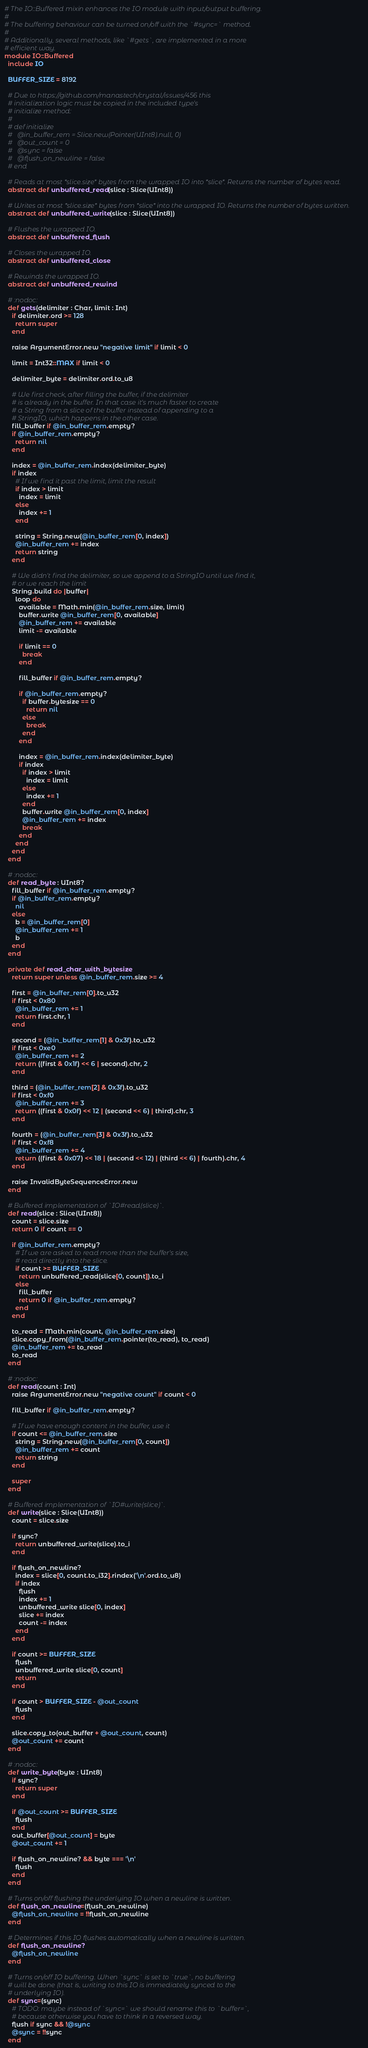Convert code to text. <code><loc_0><loc_0><loc_500><loc_500><_Crystal_># The IO::Buffered mixin enhances the IO module with input/output buffering.
#
# The buffering behaviour can be turned on/off with the `#sync=` method.
#
# Additionally, several methods, like `#gets`, are implemented in a more
# efficient way.
module IO::Buffered
  include IO

  BUFFER_SIZE = 8192

  # Due to https://github.com/manastech/crystal/issues/456 this
  # initialization logic must be copied in the included type's
  # initialize method:
  #
  # def initialize
  #   @in_buffer_rem = Slice.new(Pointer(UInt8).null, 0)
  #   @out_count = 0
  #   @sync = false
  #   @flush_on_newline = false
  # end

  # Reads at most *slice.size* bytes from the wrapped IO into *slice*. Returns the number of bytes read.
  abstract def unbuffered_read(slice : Slice(UInt8))

  # Writes at most *slice.size* bytes from *slice* into the wrapped IO. Returns the number of bytes written.
  abstract def unbuffered_write(slice : Slice(UInt8))

  # Flushes the wrapped IO.
  abstract def unbuffered_flush

  # Closes the wrapped IO.
  abstract def unbuffered_close

  # Rewinds the wrapped IO.
  abstract def unbuffered_rewind

  # :nodoc:
  def gets(delimiter : Char, limit : Int)
    if delimiter.ord >= 128
      return super
    end

    raise ArgumentError.new "negative limit" if limit < 0

    limit = Int32::MAX if limit < 0

    delimiter_byte = delimiter.ord.to_u8

    # We first check, after filling the buffer, if the delimiter
    # is already in the buffer. In that case it's much faster to create
    # a String from a slice of the buffer instead of appending to a
    # StringIO, which happens in the other case.
    fill_buffer if @in_buffer_rem.empty?
    if @in_buffer_rem.empty?
      return nil
    end

    index = @in_buffer_rem.index(delimiter_byte)
    if index
      # If we find it past the limit, limit the result
      if index > limit
        index = limit
      else
        index += 1
      end

      string = String.new(@in_buffer_rem[0, index])
      @in_buffer_rem += index
      return string
    end

    # We didn't find the delimiter, so we append to a StringIO until we find it,
    # or we reach the limit
    String.build do |buffer|
      loop do
        available = Math.min(@in_buffer_rem.size, limit)
        buffer.write @in_buffer_rem[0, available]
        @in_buffer_rem += available
        limit -= available

        if limit == 0
          break
        end

        fill_buffer if @in_buffer_rem.empty?

        if @in_buffer_rem.empty?
          if buffer.bytesize == 0
            return nil
          else
            break
          end
        end

        index = @in_buffer_rem.index(delimiter_byte)
        if index
          if index > limit
            index = limit
          else
            index += 1
          end
          buffer.write @in_buffer_rem[0, index]
          @in_buffer_rem += index
          break
        end
      end
    end
  end

  # :nodoc:
  def read_byte : UInt8?
    fill_buffer if @in_buffer_rem.empty?
    if @in_buffer_rem.empty?
      nil
    else
      b = @in_buffer_rem[0]
      @in_buffer_rem += 1
      b
    end
  end

  private def read_char_with_bytesize
    return super unless @in_buffer_rem.size >= 4

    first = @in_buffer_rem[0].to_u32
    if first < 0x80
      @in_buffer_rem += 1
      return first.chr, 1
    end

    second = (@in_buffer_rem[1] & 0x3f).to_u32
    if first < 0xe0
      @in_buffer_rem += 2
      return ((first & 0x1f) << 6 | second).chr, 2
    end

    third = (@in_buffer_rem[2] & 0x3f).to_u32
    if first < 0xf0
      @in_buffer_rem += 3
      return ((first & 0x0f) << 12 | (second << 6) | third).chr, 3
    end

    fourth = (@in_buffer_rem[3] & 0x3f).to_u32
    if first < 0xf8
      @in_buffer_rem += 4
      return ((first & 0x07) << 18 | (second << 12) | (third << 6) | fourth).chr, 4
    end

    raise InvalidByteSequenceError.new
  end

  # Buffered implementation of `IO#read(slice)`.
  def read(slice : Slice(UInt8))
    count = slice.size
    return 0 if count == 0

    if @in_buffer_rem.empty?
      # If we are asked to read more than the buffer's size,
      # read directly into the slice.
      if count >= BUFFER_SIZE
        return unbuffered_read(slice[0, count]).to_i
      else
        fill_buffer
        return 0 if @in_buffer_rem.empty?
      end
    end

    to_read = Math.min(count, @in_buffer_rem.size)
    slice.copy_from(@in_buffer_rem.pointer(to_read), to_read)
    @in_buffer_rem += to_read
    to_read
  end

  # :nodoc:
  def read(count : Int)
    raise ArgumentError.new "negative count" if count < 0

    fill_buffer if @in_buffer_rem.empty?

    # If we have enough content in the buffer, use it
    if count <= @in_buffer_rem.size
      string = String.new(@in_buffer_rem[0, count])
      @in_buffer_rem += count
      return string
    end

    super
  end

  # Buffered implementation of `IO#write(slice)`.
  def write(slice : Slice(UInt8))
    count = slice.size

    if sync?
      return unbuffered_write(slice).to_i
    end

    if flush_on_newline?
      index = slice[0, count.to_i32].rindex('\n'.ord.to_u8)
      if index
        flush
        index += 1
        unbuffered_write slice[0, index]
        slice += index
        count -= index
      end
    end

    if count >= BUFFER_SIZE
      flush
      unbuffered_write slice[0, count]
      return
    end

    if count > BUFFER_SIZE - @out_count
      flush
    end

    slice.copy_to(out_buffer + @out_count, count)
    @out_count += count
  end

  # :nodoc:
  def write_byte(byte : UInt8)
    if sync?
      return super
    end

    if @out_count >= BUFFER_SIZE
      flush
    end
    out_buffer[@out_count] = byte
    @out_count += 1

    if flush_on_newline? && byte === '\n'
      flush
    end
  end

  # Turns on/off flushing the underlying IO when a newline is written.
  def flush_on_newline=(flush_on_newline)
    @flush_on_newline = !!flush_on_newline
  end

  # Determines if this IO flushes automatically when a newline is written.
  def flush_on_newline?
    @flush_on_newline
  end

  # Turns on/off IO buffering. When `sync` is set to `true`, no buffering
  # will be done (that is, writing to this IO is immediately synced to the
  # underlying IO).
  def sync=(sync)
    # TODO: maybe instead of `sync=` we should rename this to `buffer=`,
    # because otherwise you have to think in a reversed way.
    flush if sync && !@sync
    @sync = !!sync
  end
</code> 